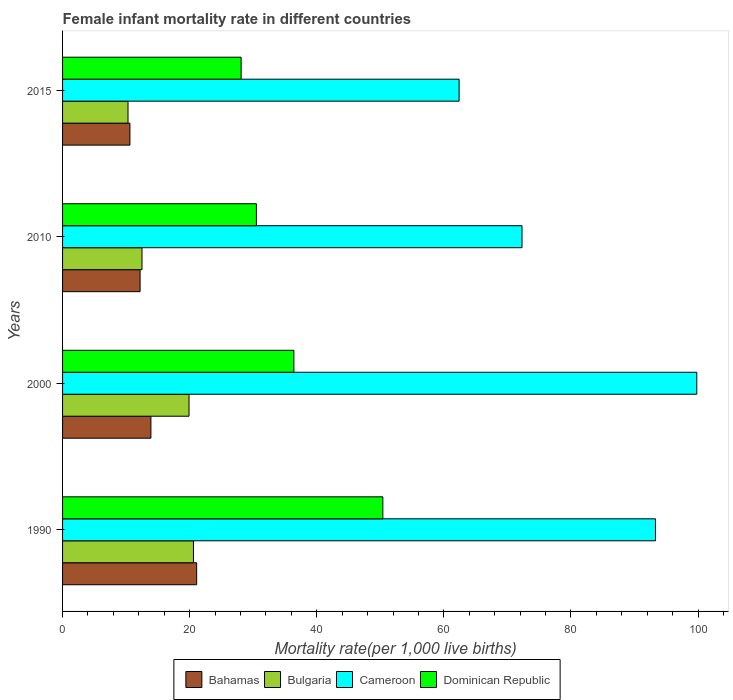Are the number of bars per tick equal to the number of legend labels?
Keep it short and to the point. Yes. Are the number of bars on each tick of the Y-axis equal?
Your answer should be compact. Yes. How many bars are there on the 3rd tick from the top?
Keep it short and to the point. 4. How many bars are there on the 2nd tick from the bottom?
Make the answer very short. 4. What is the female infant mortality rate in Cameroon in 2015?
Give a very brief answer. 62.4. Across all years, what is the maximum female infant mortality rate in Bahamas?
Provide a short and direct response. 21.1. In which year was the female infant mortality rate in Bulgaria minimum?
Provide a succinct answer. 2015. What is the total female infant mortality rate in Bulgaria in the graph?
Offer a terse response. 63.3. What is the difference between the female infant mortality rate in Bahamas in 1990 and that in 2015?
Your answer should be compact. 10.5. What is the difference between the female infant mortality rate in Cameroon in 2000 and the female infant mortality rate in Bahamas in 2015?
Ensure brevity in your answer.  89.2. What is the average female infant mortality rate in Cameroon per year?
Provide a short and direct response. 81.95. In the year 2010, what is the difference between the female infant mortality rate in Bulgaria and female infant mortality rate in Bahamas?
Provide a succinct answer. 0.3. Is the female infant mortality rate in Bulgaria in 1990 less than that in 2000?
Give a very brief answer. No. Is the difference between the female infant mortality rate in Bulgaria in 2000 and 2015 greater than the difference between the female infant mortality rate in Bahamas in 2000 and 2015?
Offer a very short reply. Yes. What is the difference between the highest and the lowest female infant mortality rate in Dominican Republic?
Make the answer very short. 22.3. What does the 1st bar from the top in 2010 represents?
Keep it short and to the point. Dominican Republic. What does the 1st bar from the bottom in 1990 represents?
Your answer should be very brief. Bahamas. How many bars are there?
Your answer should be compact. 16. How many years are there in the graph?
Keep it short and to the point. 4. What is the difference between two consecutive major ticks on the X-axis?
Your answer should be very brief. 20. Are the values on the major ticks of X-axis written in scientific E-notation?
Keep it short and to the point. No. Where does the legend appear in the graph?
Your answer should be compact. Bottom center. What is the title of the graph?
Your response must be concise. Female infant mortality rate in different countries. Does "Chile" appear as one of the legend labels in the graph?
Provide a short and direct response. No. What is the label or title of the X-axis?
Keep it short and to the point. Mortality rate(per 1,0 live births). What is the Mortality rate(per 1,000 live births) of Bahamas in 1990?
Your answer should be very brief. 21.1. What is the Mortality rate(per 1,000 live births) in Bulgaria in 1990?
Your response must be concise. 20.6. What is the Mortality rate(per 1,000 live births) in Cameroon in 1990?
Provide a short and direct response. 93.3. What is the Mortality rate(per 1,000 live births) in Dominican Republic in 1990?
Your answer should be compact. 50.4. What is the Mortality rate(per 1,000 live births) of Bulgaria in 2000?
Provide a short and direct response. 19.9. What is the Mortality rate(per 1,000 live births) of Cameroon in 2000?
Give a very brief answer. 99.8. What is the Mortality rate(per 1,000 live births) in Dominican Republic in 2000?
Offer a terse response. 36.4. What is the Mortality rate(per 1,000 live births) in Bahamas in 2010?
Your response must be concise. 12.2. What is the Mortality rate(per 1,000 live births) of Bulgaria in 2010?
Provide a succinct answer. 12.5. What is the Mortality rate(per 1,000 live births) in Cameroon in 2010?
Give a very brief answer. 72.3. What is the Mortality rate(per 1,000 live births) of Dominican Republic in 2010?
Your response must be concise. 30.5. What is the Mortality rate(per 1,000 live births) of Bahamas in 2015?
Keep it short and to the point. 10.6. What is the Mortality rate(per 1,000 live births) of Bulgaria in 2015?
Your answer should be very brief. 10.3. What is the Mortality rate(per 1,000 live births) of Cameroon in 2015?
Your response must be concise. 62.4. What is the Mortality rate(per 1,000 live births) in Dominican Republic in 2015?
Ensure brevity in your answer.  28.1. Across all years, what is the maximum Mortality rate(per 1,000 live births) of Bahamas?
Your answer should be very brief. 21.1. Across all years, what is the maximum Mortality rate(per 1,000 live births) of Bulgaria?
Keep it short and to the point. 20.6. Across all years, what is the maximum Mortality rate(per 1,000 live births) of Cameroon?
Provide a short and direct response. 99.8. Across all years, what is the maximum Mortality rate(per 1,000 live births) of Dominican Republic?
Offer a terse response. 50.4. Across all years, what is the minimum Mortality rate(per 1,000 live births) of Bulgaria?
Your response must be concise. 10.3. Across all years, what is the minimum Mortality rate(per 1,000 live births) in Cameroon?
Your answer should be compact. 62.4. Across all years, what is the minimum Mortality rate(per 1,000 live births) in Dominican Republic?
Make the answer very short. 28.1. What is the total Mortality rate(per 1,000 live births) of Bahamas in the graph?
Ensure brevity in your answer.  57.8. What is the total Mortality rate(per 1,000 live births) in Bulgaria in the graph?
Make the answer very short. 63.3. What is the total Mortality rate(per 1,000 live births) of Cameroon in the graph?
Ensure brevity in your answer.  327.8. What is the total Mortality rate(per 1,000 live births) of Dominican Republic in the graph?
Offer a very short reply. 145.4. What is the difference between the Mortality rate(per 1,000 live births) in Cameroon in 1990 and that in 2000?
Provide a succinct answer. -6.5. What is the difference between the Mortality rate(per 1,000 live births) of Bahamas in 1990 and that in 2010?
Your answer should be compact. 8.9. What is the difference between the Mortality rate(per 1,000 live births) in Bulgaria in 1990 and that in 2010?
Provide a succinct answer. 8.1. What is the difference between the Mortality rate(per 1,000 live births) of Cameroon in 1990 and that in 2010?
Provide a succinct answer. 21. What is the difference between the Mortality rate(per 1,000 live births) in Dominican Republic in 1990 and that in 2010?
Give a very brief answer. 19.9. What is the difference between the Mortality rate(per 1,000 live births) of Bahamas in 1990 and that in 2015?
Offer a very short reply. 10.5. What is the difference between the Mortality rate(per 1,000 live births) in Bulgaria in 1990 and that in 2015?
Your answer should be compact. 10.3. What is the difference between the Mortality rate(per 1,000 live births) of Cameroon in 1990 and that in 2015?
Provide a short and direct response. 30.9. What is the difference between the Mortality rate(per 1,000 live births) of Dominican Republic in 1990 and that in 2015?
Make the answer very short. 22.3. What is the difference between the Mortality rate(per 1,000 live births) of Bahamas in 2000 and that in 2010?
Your response must be concise. 1.7. What is the difference between the Mortality rate(per 1,000 live births) in Bulgaria in 2000 and that in 2010?
Provide a succinct answer. 7.4. What is the difference between the Mortality rate(per 1,000 live births) of Dominican Republic in 2000 and that in 2010?
Give a very brief answer. 5.9. What is the difference between the Mortality rate(per 1,000 live births) in Cameroon in 2000 and that in 2015?
Offer a terse response. 37.4. What is the difference between the Mortality rate(per 1,000 live births) of Dominican Republic in 2000 and that in 2015?
Provide a succinct answer. 8.3. What is the difference between the Mortality rate(per 1,000 live births) of Bulgaria in 2010 and that in 2015?
Provide a short and direct response. 2.2. What is the difference between the Mortality rate(per 1,000 live births) of Cameroon in 2010 and that in 2015?
Ensure brevity in your answer.  9.9. What is the difference between the Mortality rate(per 1,000 live births) of Bahamas in 1990 and the Mortality rate(per 1,000 live births) of Bulgaria in 2000?
Provide a short and direct response. 1.2. What is the difference between the Mortality rate(per 1,000 live births) of Bahamas in 1990 and the Mortality rate(per 1,000 live births) of Cameroon in 2000?
Your answer should be compact. -78.7. What is the difference between the Mortality rate(per 1,000 live births) in Bahamas in 1990 and the Mortality rate(per 1,000 live births) in Dominican Republic in 2000?
Provide a short and direct response. -15.3. What is the difference between the Mortality rate(per 1,000 live births) of Bulgaria in 1990 and the Mortality rate(per 1,000 live births) of Cameroon in 2000?
Offer a terse response. -79.2. What is the difference between the Mortality rate(per 1,000 live births) in Bulgaria in 1990 and the Mortality rate(per 1,000 live births) in Dominican Republic in 2000?
Provide a short and direct response. -15.8. What is the difference between the Mortality rate(per 1,000 live births) of Cameroon in 1990 and the Mortality rate(per 1,000 live births) of Dominican Republic in 2000?
Offer a very short reply. 56.9. What is the difference between the Mortality rate(per 1,000 live births) in Bahamas in 1990 and the Mortality rate(per 1,000 live births) in Bulgaria in 2010?
Offer a very short reply. 8.6. What is the difference between the Mortality rate(per 1,000 live births) in Bahamas in 1990 and the Mortality rate(per 1,000 live births) in Cameroon in 2010?
Keep it short and to the point. -51.2. What is the difference between the Mortality rate(per 1,000 live births) of Bahamas in 1990 and the Mortality rate(per 1,000 live births) of Dominican Republic in 2010?
Give a very brief answer. -9.4. What is the difference between the Mortality rate(per 1,000 live births) in Bulgaria in 1990 and the Mortality rate(per 1,000 live births) in Cameroon in 2010?
Your answer should be very brief. -51.7. What is the difference between the Mortality rate(per 1,000 live births) of Bulgaria in 1990 and the Mortality rate(per 1,000 live births) of Dominican Republic in 2010?
Your response must be concise. -9.9. What is the difference between the Mortality rate(per 1,000 live births) of Cameroon in 1990 and the Mortality rate(per 1,000 live births) of Dominican Republic in 2010?
Provide a succinct answer. 62.8. What is the difference between the Mortality rate(per 1,000 live births) of Bahamas in 1990 and the Mortality rate(per 1,000 live births) of Cameroon in 2015?
Offer a terse response. -41.3. What is the difference between the Mortality rate(per 1,000 live births) of Bulgaria in 1990 and the Mortality rate(per 1,000 live births) of Cameroon in 2015?
Offer a very short reply. -41.8. What is the difference between the Mortality rate(per 1,000 live births) in Bulgaria in 1990 and the Mortality rate(per 1,000 live births) in Dominican Republic in 2015?
Provide a short and direct response. -7.5. What is the difference between the Mortality rate(per 1,000 live births) of Cameroon in 1990 and the Mortality rate(per 1,000 live births) of Dominican Republic in 2015?
Provide a succinct answer. 65.2. What is the difference between the Mortality rate(per 1,000 live births) in Bahamas in 2000 and the Mortality rate(per 1,000 live births) in Bulgaria in 2010?
Keep it short and to the point. 1.4. What is the difference between the Mortality rate(per 1,000 live births) in Bahamas in 2000 and the Mortality rate(per 1,000 live births) in Cameroon in 2010?
Your answer should be compact. -58.4. What is the difference between the Mortality rate(per 1,000 live births) in Bahamas in 2000 and the Mortality rate(per 1,000 live births) in Dominican Republic in 2010?
Offer a terse response. -16.6. What is the difference between the Mortality rate(per 1,000 live births) of Bulgaria in 2000 and the Mortality rate(per 1,000 live births) of Cameroon in 2010?
Your response must be concise. -52.4. What is the difference between the Mortality rate(per 1,000 live births) in Cameroon in 2000 and the Mortality rate(per 1,000 live births) in Dominican Republic in 2010?
Your answer should be very brief. 69.3. What is the difference between the Mortality rate(per 1,000 live births) of Bahamas in 2000 and the Mortality rate(per 1,000 live births) of Bulgaria in 2015?
Your answer should be compact. 3.6. What is the difference between the Mortality rate(per 1,000 live births) of Bahamas in 2000 and the Mortality rate(per 1,000 live births) of Cameroon in 2015?
Provide a succinct answer. -48.5. What is the difference between the Mortality rate(per 1,000 live births) of Bulgaria in 2000 and the Mortality rate(per 1,000 live births) of Cameroon in 2015?
Provide a succinct answer. -42.5. What is the difference between the Mortality rate(per 1,000 live births) of Cameroon in 2000 and the Mortality rate(per 1,000 live births) of Dominican Republic in 2015?
Give a very brief answer. 71.7. What is the difference between the Mortality rate(per 1,000 live births) of Bahamas in 2010 and the Mortality rate(per 1,000 live births) of Bulgaria in 2015?
Offer a very short reply. 1.9. What is the difference between the Mortality rate(per 1,000 live births) in Bahamas in 2010 and the Mortality rate(per 1,000 live births) in Cameroon in 2015?
Provide a succinct answer. -50.2. What is the difference between the Mortality rate(per 1,000 live births) in Bahamas in 2010 and the Mortality rate(per 1,000 live births) in Dominican Republic in 2015?
Make the answer very short. -15.9. What is the difference between the Mortality rate(per 1,000 live births) in Bulgaria in 2010 and the Mortality rate(per 1,000 live births) in Cameroon in 2015?
Your response must be concise. -49.9. What is the difference between the Mortality rate(per 1,000 live births) in Bulgaria in 2010 and the Mortality rate(per 1,000 live births) in Dominican Republic in 2015?
Your answer should be very brief. -15.6. What is the difference between the Mortality rate(per 1,000 live births) of Cameroon in 2010 and the Mortality rate(per 1,000 live births) of Dominican Republic in 2015?
Give a very brief answer. 44.2. What is the average Mortality rate(per 1,000 live births) of Bahamas per year?
Your answer should be very brief. 14.45. What is the average Mortality rate(per 1,000 live births) in Bulgaria per year?
Give a very brief answer. 15.82. What is the average Mortality rate(per 1,000 live births) in Cameroon per year?
Your answer should be compact. 81.95. What is the average Mortality rate(per 1,000 live births) in Dominican Republic per year?
Keep it short and to the point. 36.35. In the year 1990, what is the difference between the Mortality rate(per 1,000 live births) in Bahamas and Mortality rate(per 1,000 live births) in Bulgaria?
Offer a very short reply. 0.5. In the year 1990, what is the difference between the Mortality rate(per 1,000 live births) in Bahamas and Mortality rate(per 1,000 live births) in Cameroon?
Your response must be concise. -72.2. In the year 1990, what is the difference between the Mortality rate(per 1,000 live births) in Bahamas and Mortality rate(per 1,000 live births) in Dominican Republic?
Provide a succinct answer. -29.3. In the year 1990, what is the difference between the Mortality rate(per 1,000 live births) of Bulgaria and Mortality rate(per 1,000 live births) of Cameroon?
Offer a terse response. -72.7. In the year 1990, what is the difference between the Mortality rate(per 1,000 live births) of Bulgaria and Mortality rate(per 1,000 live births) of Dominican Republic?
Provide a succinct answer. -29.8. In the year 1990, what is the difference between the Mortality rate(per 1,000 live births) in Cameroon and Mortality rate(per 1,000 live births) in Dominican Republic?
Give a very brief answer. 42.9. In the year 2000, what is the difference between the Mortality rate(per 1,000 live births) in Bahamas and Mortality rate(per 1,000 live births) in Bulgaria?
Your response must be concise. -6. In the year 2000, what is the difference between the Mortality rate(per 1,000 live births) of Bahamas and Mortality rate(per 1,000 live births) of Cameroon?
Make the answer very short. -85.9. In the year 2000, what is the difference between the Mortality rate(per 1,000 live births) in Bahamas and Mortality rate(per 1,000 live births) in Dominican Republic?
Provide a succinct answer. -22.5. In the year 2000, what is the difference between the Mortality rate(per 1,000 live births) of Bulgaria and Mortality rate(per 1,000 live births) of Cameroon?
Provide a succinct answer. -79.9. In the year 2000, what is the difference between the Mortality rate(per 1,000 live births) of Bulgaria and Mortality rate(per 1,000 live births) of Dominican Republic?
Give a very brief answer. -16.5. In the year 2000, what is the difference between the Mortality rate(per 1,000 live births) in Cameroon and Mortality rate(per 1,000 live births) in Dominican Republic?
Give a very brief answer. 63.4. In the year 2010, what is the difference between the Mortality rate(per 1,000 live births) in Bahamas and Mortality rate(per 1,000 live births) in Bulgaria?
Make the answer very short. -0.3. In the year 2010, what is the difference between the Mortality rate(per 1,000 live births) of Bahamas and Mortality rate(per 1,000 live births) of Cameroon?
Offer a terse response. -60.1. In the year 2010, what is the difference between the Mortality rate(per 1,000 live births) in Bahamas and Mortality rate(per 1,000 live births) in Dominican Republic?
Provide a succinct answer. -18.3. In the year 2010, what is the difference between the Mortality rate(per 1,000 live births) in Bulgaria and Mortality rate(per 1,000 live births) in Cameroon?
Your answer should be very brief. -59.8. In the year 2010, what is the difference between the Mortality rate(per 1,000 live births) of Bulgaria and Mortality rate(per 1,000 live births) of Dominican Republic?
Your answer should be compact. -18. In the year 2010, what is the difference between the Mortality rate(per 1,000 live births) of Cameroon and Mortality rate(per 1,000 live births) of Dominican Republic?
Keep it short and to the point. 41.8. In the year 2015, what is the difference between the Mortality rate(per 1,000 live births) of Bahamas and Mortality rate(per 1,000 live births) of Bulgaria?
Offer a very short reply. 0.3. In the year 2015, what is the difference between the Mortality rate(per 1,000 live births) in Bahamas and Mortality rate(per 1,000 live births) in Cameroon?
Offer a very short reply. -51.8. In the year 2015, what is the difference between the Mortality rate(per 1,000 live births) of Bahamas and Mortality rate(per 1,000 live births) of Dominican Republic?
Your response must be concise. -17.5. In the year 2015, what is the difference between the Mortality rate(per 1,000 live births) in Bulgaria and Mortality rate(per 1,000 live births) in Cameroon?
Provide a succinct answer. -52.1. In the year 2015, what is the difference between the Mortality rate(per 1,000 live births) of Bulgaria and Mortality rate(per 1,000 live births) of Dominican Republic?
Make the answer very short. -17.8. In the year 2015, what is the difference between the Mortality rate(per 1,000 live births) in Cameroon and Mortality rate(per 1,000 live births) in Dominican Republic?
Your answer should be compact. 34.3. What is the ratio of the Mortality rate(per 1,000 live births) in Bahamas in 1990 to that in 2000?
Offer a terse response. 1.52. What is the ratio of the Mortality rate(per 1,000 live births) of Bulgaria in 1990 to that in 2000?
Give a very brief answer. 1.04. What is the ratio of the Mortality rate(per 1,000 live births) in Cameroon in 1990 to that in 2000?
Your response must be concise. 0.93. What is the ratio of the Mortality rate(per 1,000 live births) of Dominican Republic in 1990 to that in 2000?
Offer a terse response. 1.38. What is the ratio of the Mortality rate(per 1,000 live births) in Bahamas in 1990 to that in 2010?
Provide a short and direct response. 1.73. What is the ratio of the Mortality rate(per 1,000 live births) in Bulgaria in 1990 to that in 2010?
Ensure brevity in your answer.  1.65. What is the ratio of the Mortality rate(per 1,000 live births) of Cameroon in 1990 to that in 2010?
Give a very brief answer. 1.29. What is the ratio of the Mortality rate(per 1,000 live births) in Dominican Republic in 1990 to that in 2010?
Your answer should be very brief. 1.65. What is the ratio of the Mortality rate(per 1,000 live births) in Bahamas in 1990 to that in 2015?
Keep it short and to the point. 1.99. What is the ratio of the Mortality rate(per 1,000 live births) of Bulgaria in 1990 to that in 2015?
Provide a short and direct response. 2. What is the ratio of the Mortality rate(per 1,000 live births) in Cameroon in 1990 to that in 2015?
Your response must be concise. 1.5. What is the ratio of the Mortality rate(per 1,000 live births) of Dominican Republic in 1990 to that in 2015?
Ensure brevity in your answer.  1.79. What is the ratio of the Mortality rate(per 1,000 live births) in Bahamas in 2000 to that in 2010?
Make the answer very short. 1.14. What is the ratio of the Mortality rate(per 1,000 live births) in Bulgaria in 2000 to that in 2010?
Your answer should be very brief. 1.59. What is the ratio of the Mortality rate(per 1,000 live births) in Cameroon in 2000 to that in 2010?
Provide a short and direct response. 1.38. What is the ratio of the Mortality rate(per 1,000 live births) of Dominican Republic in 2000 to that in 2010?
Offer a very short reply. 1.19. What is the ratio of the Mortality rate(per 1,000 live births) in Bahamas in 2000 to that in 2015?
Make the answer very short. 1.31. What is the ratio of the Mortality rate(per 1,000 live births) of Bulgaria in 2000 to that in 2015?
Keep it short and to the point. 1.93. What is the ratio of the Mortality rate(per 1,000 live births) in Cameroon in 2000 to that in 2015?
Provide a succinct answer. 1.6. What is the ratio of the Mortality rate(per 1,000 live births) in Dominican Republic in 2000 to that in 2015?
Ensure brevity in your answer.  1.3. What is the ratio of the Mortality rate(per 1,000 live births) in Bahamas in 2010 to that in 2015?
Keep it short and to the point. 1.15. What is the ratio of the Mortality rate(per 1,000 live births) of Bulgaria in 2010 to that in 2015?
Give a very brief answer. 1.21. What is the ratio of the Mortality rate(per 1,000 live births) in Cameroon in 2010 to that in 2015?
Offer a terse response. 1.16. What is the ratio of the Mortality rate(per 1,000 live births) of Dominican Republic in 2010 to that in 2015?
Provide a short and direct response. 1.09. What is the difference between the highest and the second highest Mortality rate(per 1,000 live births) in Bulgaria?
Your answer should be very brief. 0.7. What is the difference between the highest and the lowest Mortality rate(per 1,000 live births) of Bahamas?
Make the answer very short. 10.5. What is the difference between the highest and the lowest Mortality rate(per 1,000 live births) in Bulgaria?
Provide a succinct answer. 10.3. What is the difference between the highest and the lowest Mortality rate(per 1,000 live births) of Cameroon?
Offer a terse response. 37.4. What is the difference between the highest and the lowest Mortality rate(per 1,000 live births) in Dominican Republic?
Ensure brevity in your answer.  22.3. 